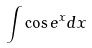<formula> <loc_0><loc_0><loc_500><loc_500>\int \cos e ^ { x } d x</formula> 